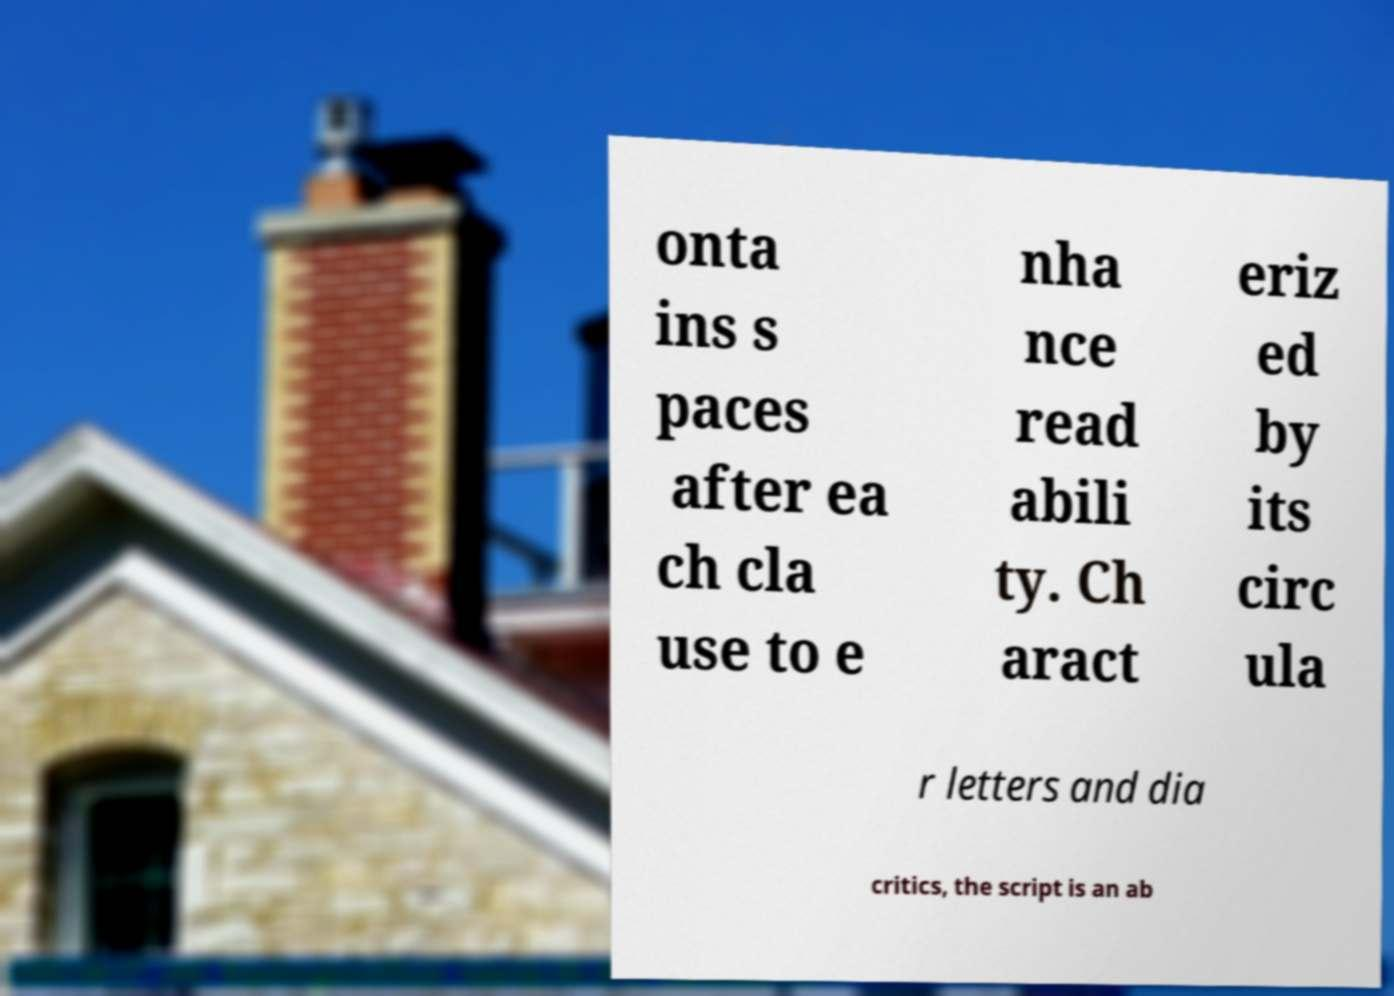Can you accurately transcribe the text from the provided image for me? onta ins s paces after ea ch cla use to e nha nce read abili ty. Ch aract eriz ed by its circ ula r letters and dia critics, the script is an ab 